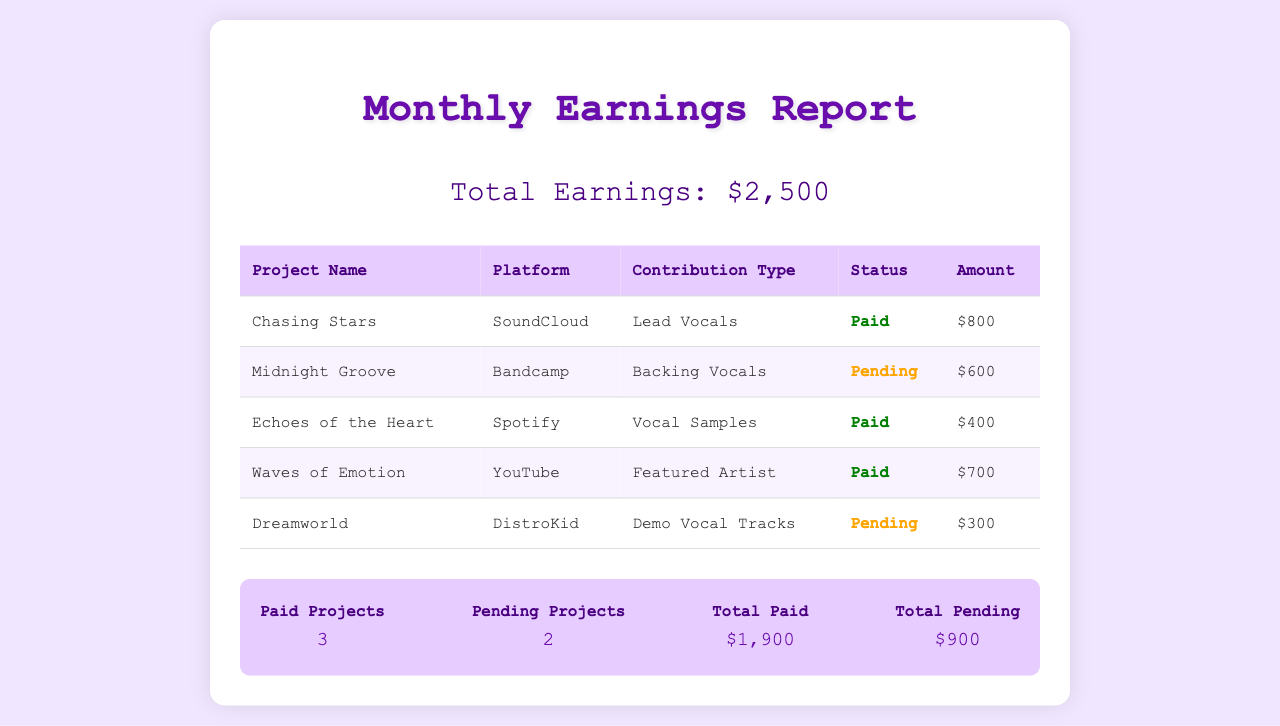What is the total earnings? The total earnings are stated prominently in the report as $2,500.
Answer: $2,500 How many projects are marked as paid? The summary section indicates there are 3 projects that are marked as paid.
Answer: 3 What is the contribution type for 'Chasing Stars'? The table shows that the contribution type for 'Chasing Stars' is Lead Vocals.
Answer: Lead Vocals Which platform is associated with the project 'Midnight Groove'? The table lists Bandcamp as the platform for the project 'Midnight Groove'.
Answer: Bandcamp What is the amount for the pending project 'Dreamworld'? The table specifies that the amount for 'Dreamworld' is $300.
Answer: $300 How many projects are pending payment? According to the summary, there are 2 pending projects.
Answer: 2 What is the total amount for paid projects? The summary states that the total amount for paid projects is $1,900.
Answer: $1,900 Which project has the largest earning? The table indicates that 'Chasing Stars' has the largest earning at $800.
Answer: Chasing Stars What percentage of total earnings is pending? With total earnings of $2,500 and pending amounts of $900, the pending percentage is 36%.
Answer: 36% 